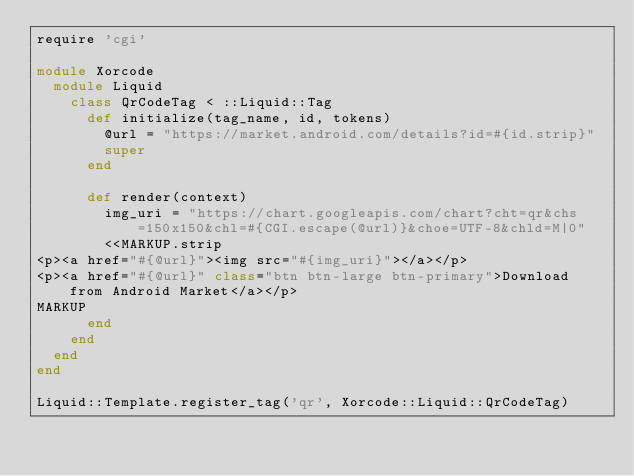Convert code to text. <code><loc_0><loc_0><loc_500><loc_500><_Ruby_>require 'cgi'

module Xorcode
  module Liquid
    class QrCodeTag < ::Liquid::Tag
      def initialize(tag_name, id, tokens)
        @url = "https://market.android.com/details?id=#{id.strip}"
        super
      end

      def render(context)
        img_uri = "https://chart.googleapis.com/chart?cht=qr&chs=150x150&chl=#{CGI.escape(@url)}&choe=UTF-8&chld=M|0"
        <<MARKUP.strip
<p><a href="#{@url}"><img src="#{img_uri}"></a></p>
<p><a href="#{@url}" class="btn btn-large btn-primary">Download from Android Market</a></p>
MARKUP
      end
    end
  end
end

Liquid::Template.register_tag('qr', Xorcode::Liquid::QrCodeTag)
</code> 